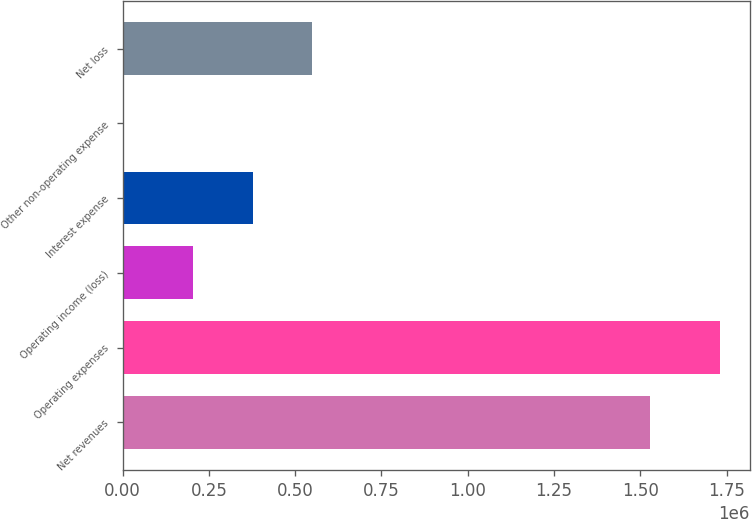Convert chart. <chart><loc_0><loc_0><loc_500><loc_500><bar_chart><fcel>Net revenues<fcel>Operating expenses<fcel>Operating income (loss)<fcel>Interest expense<fcel>Other non-operating expense<fcel>Net loss<nl><fcel>1.52736e+06<fcel>1.73126e+06<fcel>203908<fcel>376501<fcel>5329<fcel>549095<nl></chart> 